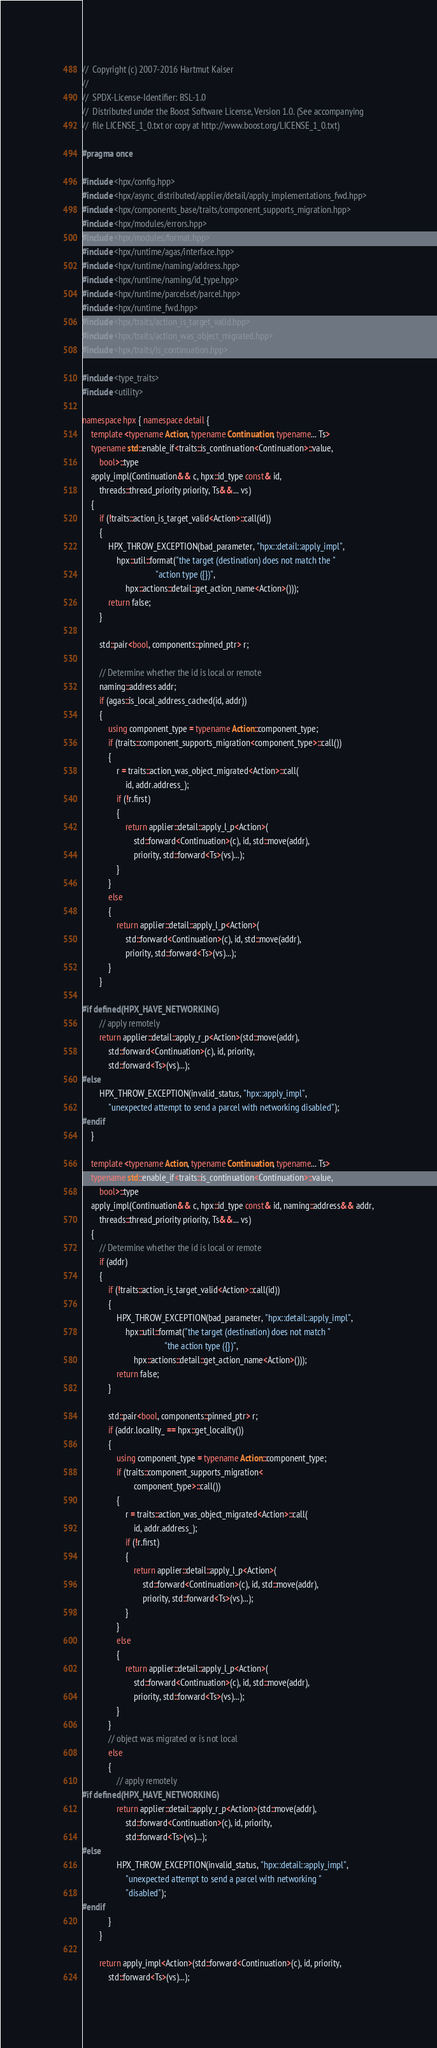Convert code to text. <code><loc_0><loc_0><loc_500><loc_500><_C++_>//  Copyright (c) 2007-2016 Hartmut Kaiser
//
//  SPDX-License-Identifier: BSL-1.0
//  Distributed under the Boost Software License, Version 1.0. (See accompanying
//  file LICENSE_1_0.txt or copy at http://www.boost.org/LICENSE_1_0.txt)

#pragma once

#include <hpx/config.hpp>
#include <hpx/async_distributed/applier/detail/apply_implementations_fwd.hpp>
#include <hpx/components_base/traits/component_supports_migration.hpp>
#include <hpx/modules/errors.hpp>
#include <hpx/modules/format.hpp>
#include <hpx/runtime/agas/interface.hpp>
#include <hpx/runtime/naming/address.hpp>
#include <hpx/runtime/naming/id_type.hpp>
#include <hpx/runtime/parcelset/parcel.hpp>
#include <hpx/runtime_fwd.hpp>
#include <hpx/traits/action_is_target_valid.hpp>
#include <hpx/traits/action_was_object_migrated.hpp>
#include <hpx/traits/is_continuation.hpp>

#include <type_traits>
#include <utility>

namespace hpx { namespace detail {
    template <typename Action, typename Continuation, typename... Ts>
    typename std::enable_if<traits::is_continuation<Continuation>::value,
        bool>::type
    apply_impl(Continuation&& c, hpx::id_type const& id,
        threads::thread_priority priority, Ts&&... vs)
    {
        if (!traits::action_is_target_valid<Action>::call(id))
        {
            HPX_THROW_EXCEPTION(bad_parameter, "hpx::detail::apply_impl",
                hpx::util::format("the target (destination) does not match the "
                                  "action type ({})",
                    hpx::actions::detail::get_action_name<Action>()));
            return false;
        }

        std::pair<bool, components::pinned_ptr> r;

        // Determine whether the id is local or remote
        naming::address addr;
        if (agas::is_local_address_cached(id, addr))
        {
            using component_type = typename Action::component_type;
            if (traits::component_supports_migration<component_type>::call())
            {
                r = traits::action_was_object_migrated<Action>::call(
                    id, addr.address_);
                if (!r.first)
                {
                    return applier::detail::apply_l_p<Action>(
                        std::forward<Continuation>(c), id, std::move(addr),
                        priority, std::forward<Ts>(vs)...);
                }
            }
            else
            {
                return applier::detail::apply_l_p<Action>(
                    std::forward<Continuation>(c), id, std::move(addr),
                    priority, std::forward<Ts>(vs)...);
            }
        }

#if defined(HPX_HAVE_NETWORKING)
        // apply remotely
        return applier::detail::apply_r_p<Action>(std::move(addr),
            std::forward<Continuation>(c), id, priority,
            std::forward<Ts>(vs)...);
#else
        HPX_THROW_EXCEPTION(invalid_status, "hpx::apply_impl",
            "unexpected attempt to send a parcel with networking disabled");
#endif
    }

    template <typename Action, typename Continuation, typename... Ts>
    typename std::enable_if<traits::is_continuation<Continuation>::value,
        bool>::type
    apply_impl(Continuation&& c, hpx::id_type const& id, naming::address&& addr,
        threads::thread_priority priority, Ts&&... vs)
    {
        // Determine whether the id is local or remote
        if (addr)
        {
            if (!traits::action_is_target_valid<Action>::call(id))
            {
                HPX_THROW_EXCEPTION(bad_parameter, "hpx::detail::apply_impl",
                    hpx::util::format("the target (destination) does not match "
                                      "the action type ({})",
                        hpx::actions::detail::get_action_name<Action>()));
                return false;
            }

            std::pair<bool, components::pinned_ptr> r;
            if (addr.locality_ == hpx::get_locality())
            {
                using component_type = typename Action::component_type;
                if (traits::component_supports_migration<
                        component_type>::call())
                {
                    r = traits::action_was_object_migrated<Action>::call(
                        id, addr.address_);
                    if (!r.first)
                    {
                        return applier::detail::apply_l_p<Action>(
                            std::forward<Continuation>(c), id, std::move(addr),
                            priority, std::forward<Ts>(vs)...);
                    }
                }
                else
                {
                    return applier::detail::apply_l_p<Action>(
                        std::forward<Continuation>(c), id, std::move(addr),
                        priority, std::forward<Ts>(vs)...);
                }
            }
            // object was migrated or is not local
            else
            {
                // apply remotely
#if defined(HPX_HAVE_NETWORKING)
                return applier::detail::apply_r_p<Action>(std::move(addr),
                    std::forward<Continuation>(c), id, priority,
                    std::forward<Ts>(vs)...);
#else
                HPX_THROW_EXCEPTION(invalid_status, "hpx::detail::apply_impl",
                    "unexpected attempt to send a parcel with networking "
                    "disabled");
#endif
            }
        }

        return apply_impl<Action>(std::forward<Continuation>(c), id, priority,
            std::forward<Ts>(vs)...);</code> 